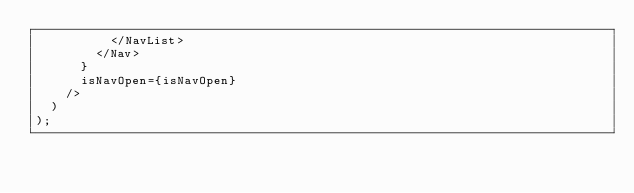<code> <loc_0><loc_0><loc_500><loc_500><_TypeScript_>          </NavList>
        </Nav>
      }
      isNavOpen={isNavOpen}
    />
  )
);
</code> 